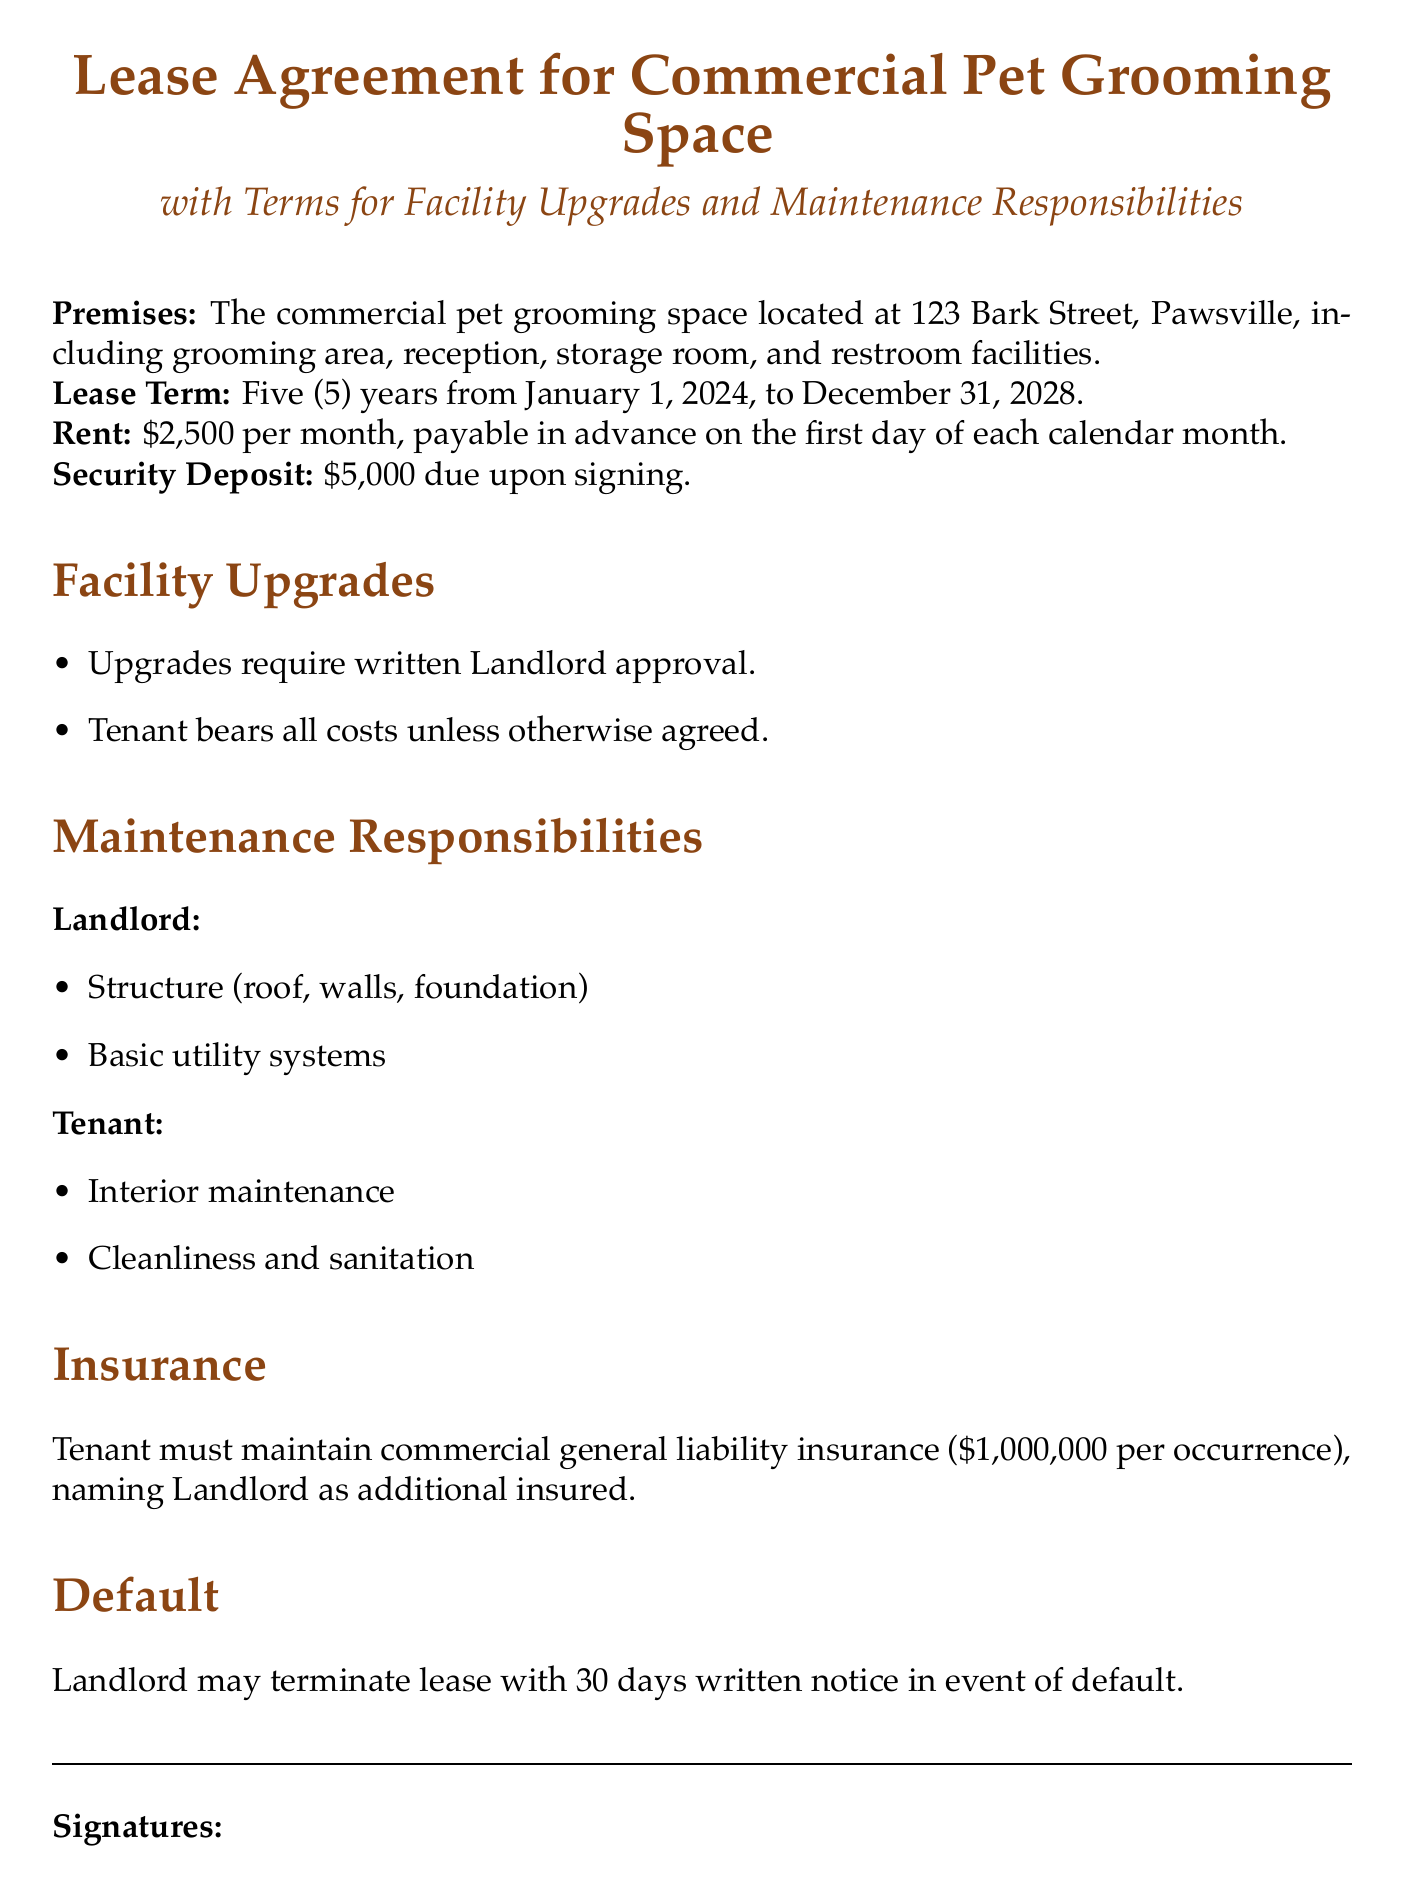What is the address of the commercial pet grooming space? The address is specified in the document under the premises section.
Answer: 123 Bark Street, Pawsville What is the monthly rent amount? The rent amount is indicated in the lease agreement details concerning payments.
Answer: $2,500 What is the duration of the lease term? The lease term duration is provided at the beginning of the document.
Answer: Five years What is the security deposit required? The security deposit amount is highlighted in the lease agreement.
Answer: $5,000 Who is responsible for the interior maintenance? The maintenance responsibilities section specifies which party handles interior tasks.
Answer: Tenant What is the insurance requirement for the tenant? The insurance requirement includes the type and amount stipulated in the lease agreement.
Answer: $1,000,000 per occurrence What happens in case of a default? The document outlines the consequences in the event of a default by the tenant.
Answer: Landlord may terminate lease with 30 days written notice Are upgrades allowed without approval? The facility upgrades section indicates if approval is necessary for upgrades.
Answer: No What are the landlord's maintenance responsibilities? The landlord's responsibilities related to maintenance are listed in the document.
Answer: Structure (roof, walls, foundation) 